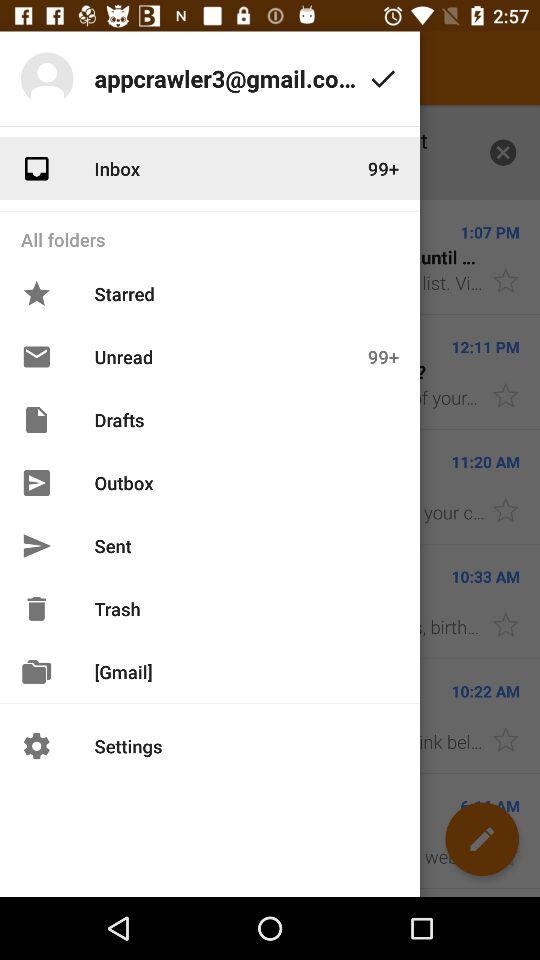How many unread emails are in the Inbox folder?
Answer the question using a single word or phrase. 99+ 